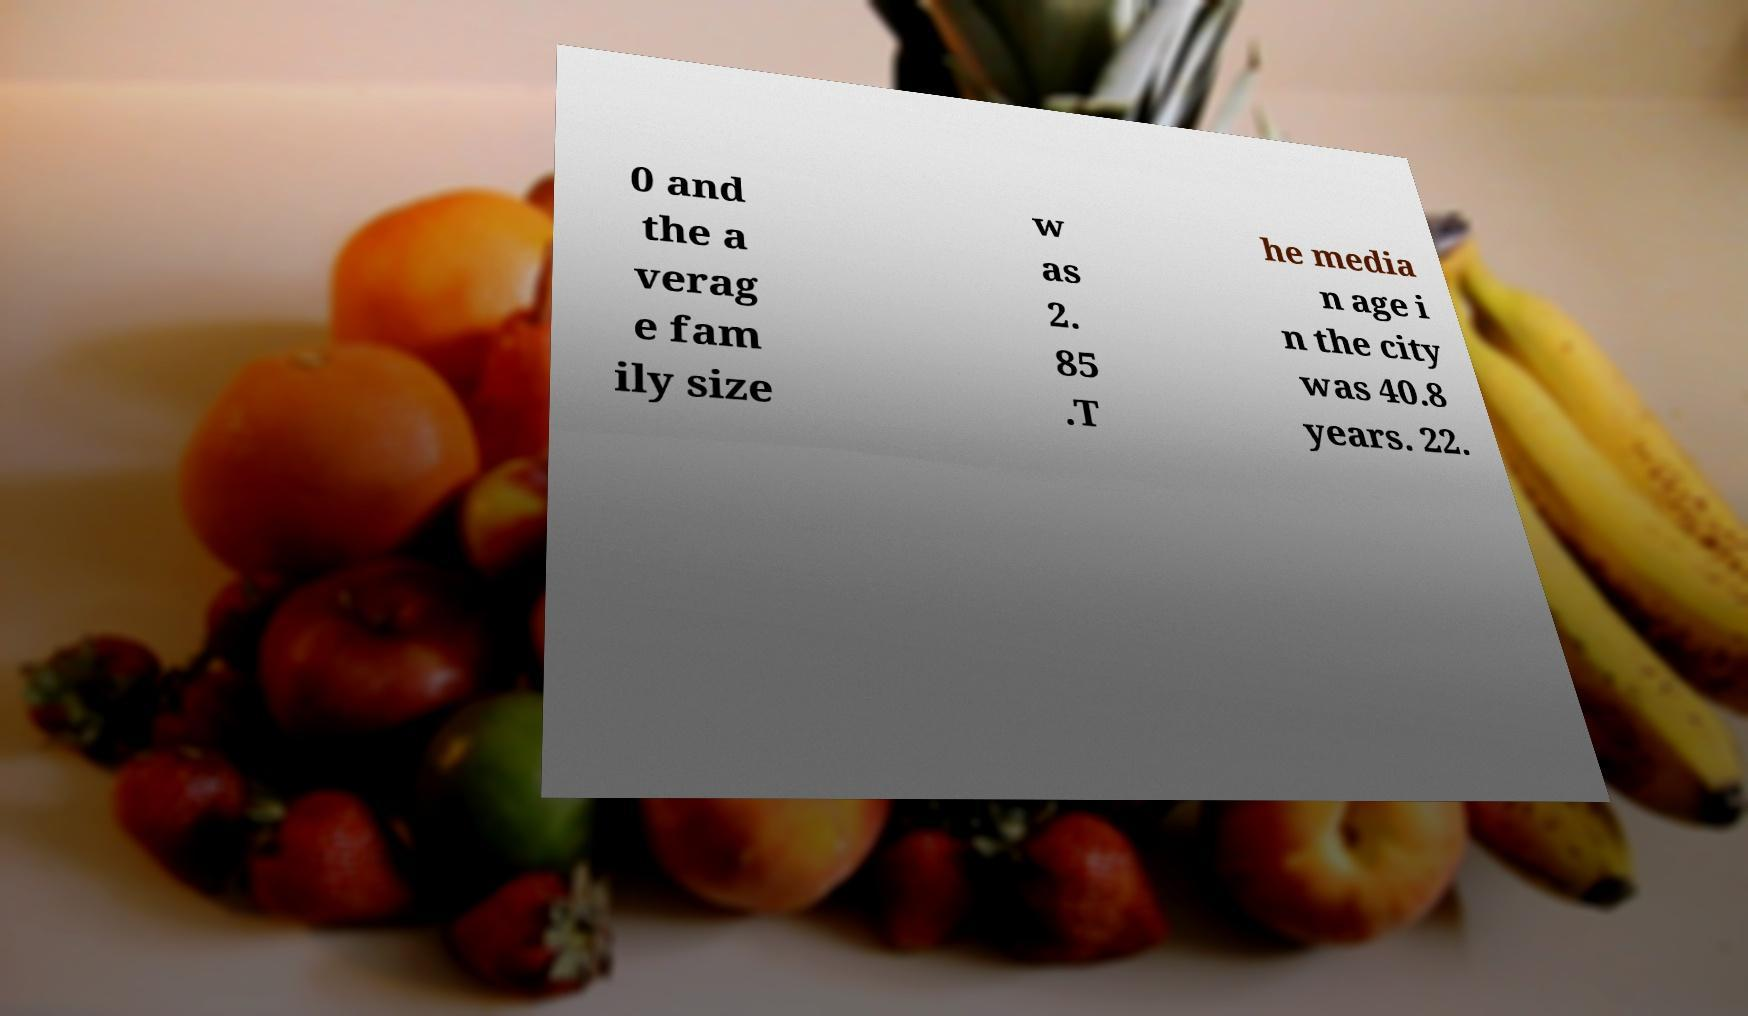What messages or text are displayed in this image? I need them in a readable, typed format. 0 and the a verag e fam ily size w as 2. 85 .T he media n age i n the city was 40.8 years. 22. 